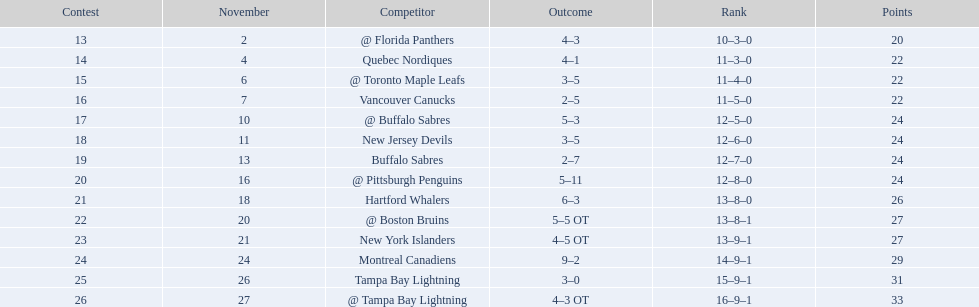What are the teams in the atlantic division? Quebec Nordiques, Vancouver Canucks, New Jersey Devils, Buffalo Sabres, Hartford Whalers, New York Islanders, Montreal Canadiens, Tampa Bay Lightning. Which of those scored fewer points than the philadelphia flyers? Tampa Bay Lightning. 